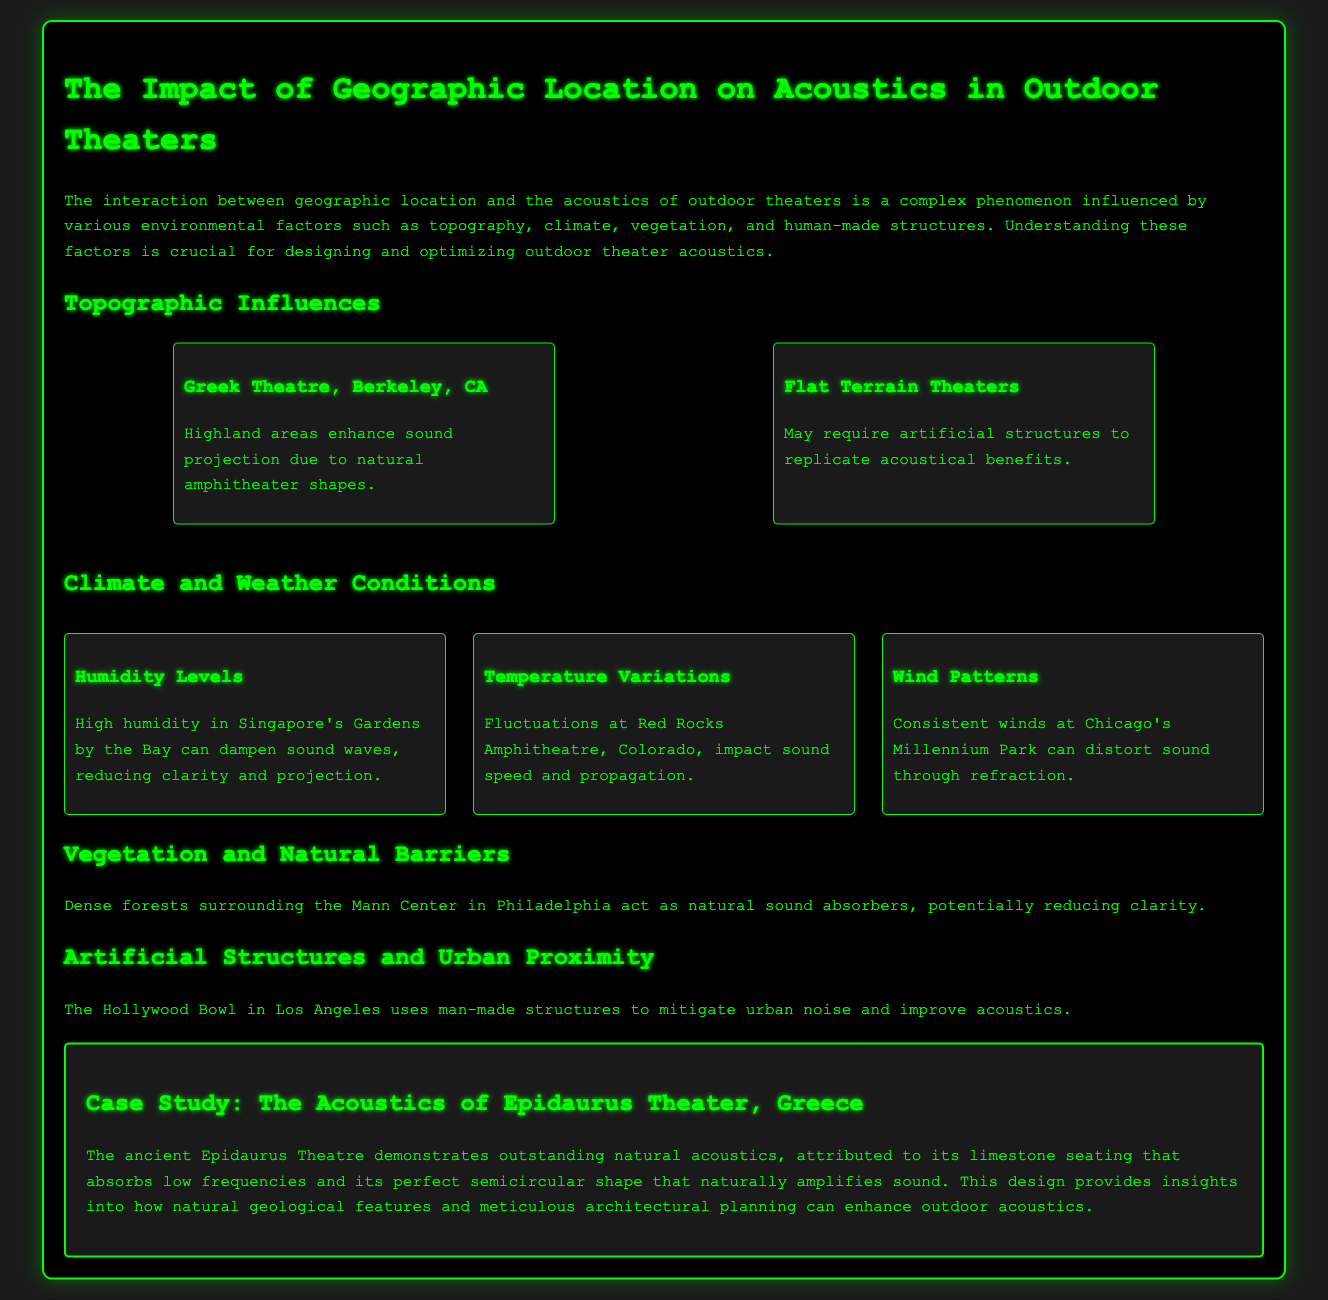What are the geographic influences on outdoor theater acoustics? The document discusses topography, climate, vegetation, and artificial structures as geographic influences.
Answer: Topography Which theater enhances sound projection due to its natural shape? The document specifically mentions the Greek Theatre in Berkeley, CA, as having natural amphitheater shapes.
Answer: Greek Theatre, Berkeley, CA What factor is affected by humidity levels in Singapore's Gardens by the Bay? High humidity dampens sound waves, reducing clarity and projection according to the document.
Answer: Clarity What natural sound absorbers surround the Mann Center in Philadelphia? The document states that dense forests act as natural sound absorbers.
Answer: Dense forests What urban theater mitigates noise with man-made structures? The Hollywood Bowl in Los Angeles uses artificial structures for this purpose.
Answer: Hollywood Bowl How does temperature variation impact sound at Red Rocks Amphitheatre? The document notes that fluctuations in temperature impact sound speed and propagation.
Answer: Sound speed Which ancient theater demonstrates outstanding natural acoustics? The case study highlights Epidaurus Theatre as having remarkable acoustics.
Answer: Epidaurus Theatre What architectural feature of the Epidaurus Theatre amplifies sound? The perfect semicircular shape of the theater is noted as an amplifying feature.
Answer: Semicircular shape 